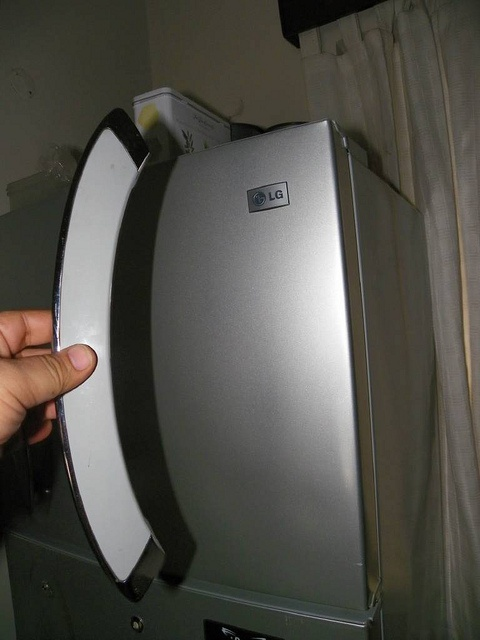Describe the objects in this image and their specific colors. I can see refrigerator in black, gray, and darkgray tones and people in black, brown, salmon, and maroon tones in this image. 